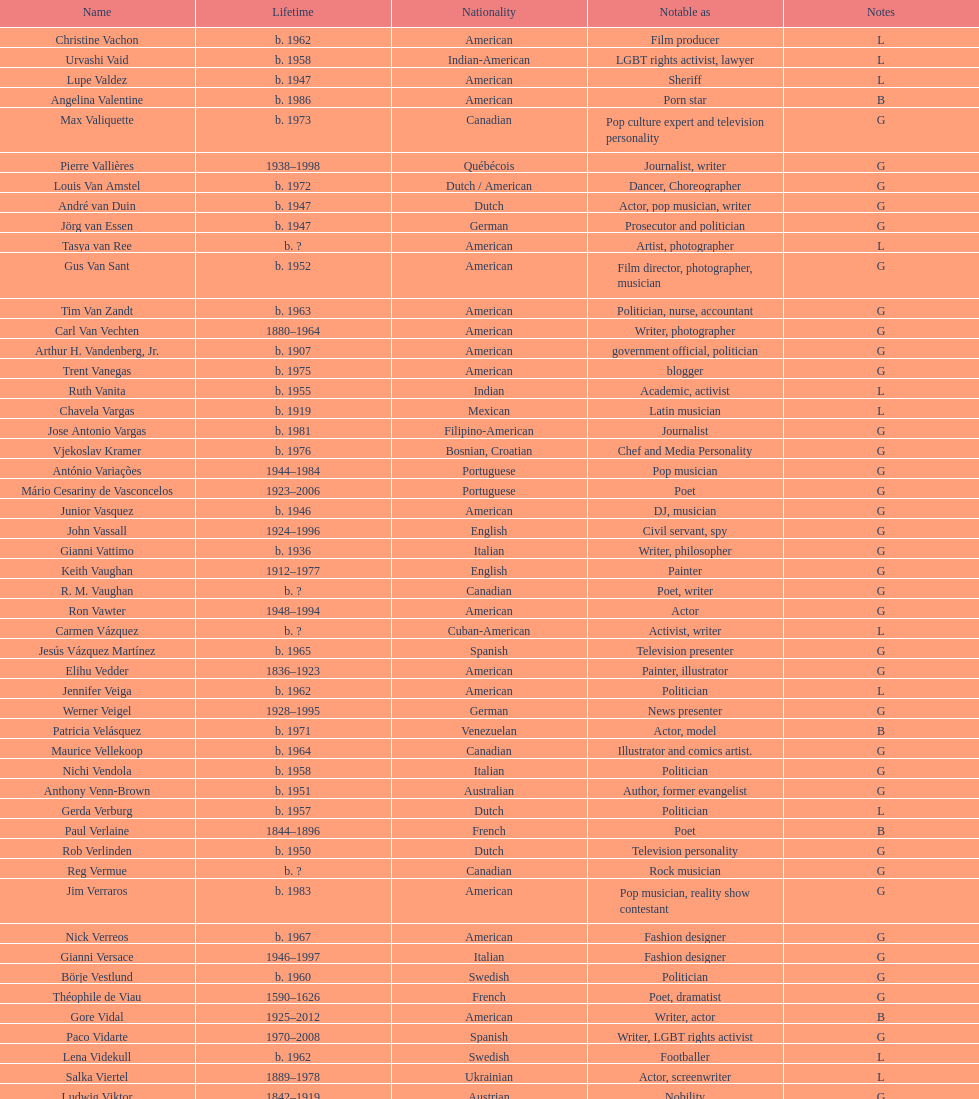What was lupe valdez's former name? Urvashi Vaid. 